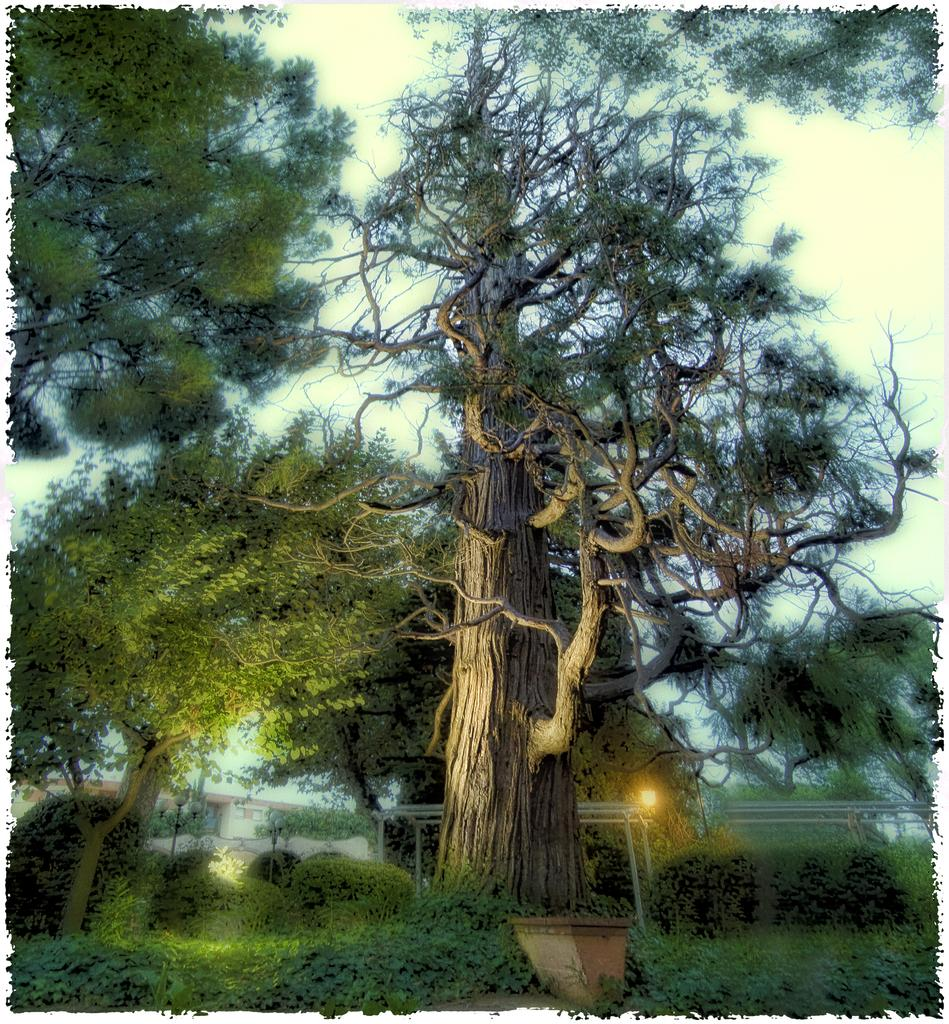What type of vegetation can be seen in the image? There are trees and plants in the image. Where are the plants located in the image? The plants are at the bottom of the image. What object is present in the image that might be used for holding plants? There is a pot in the image. What can be seen in the background of the image? The sky is visible in the background of the image. What type of poison is being sold in the shop in the image? There is no shop or poison present in the image; it features trees, plants, and a pot. Can you tell me how many ships are visible in the image? There are no ships visible in the image. 